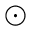<formula> <loc_0><loc_0><loc_500><loc_500>_ { \odot }</formula> 